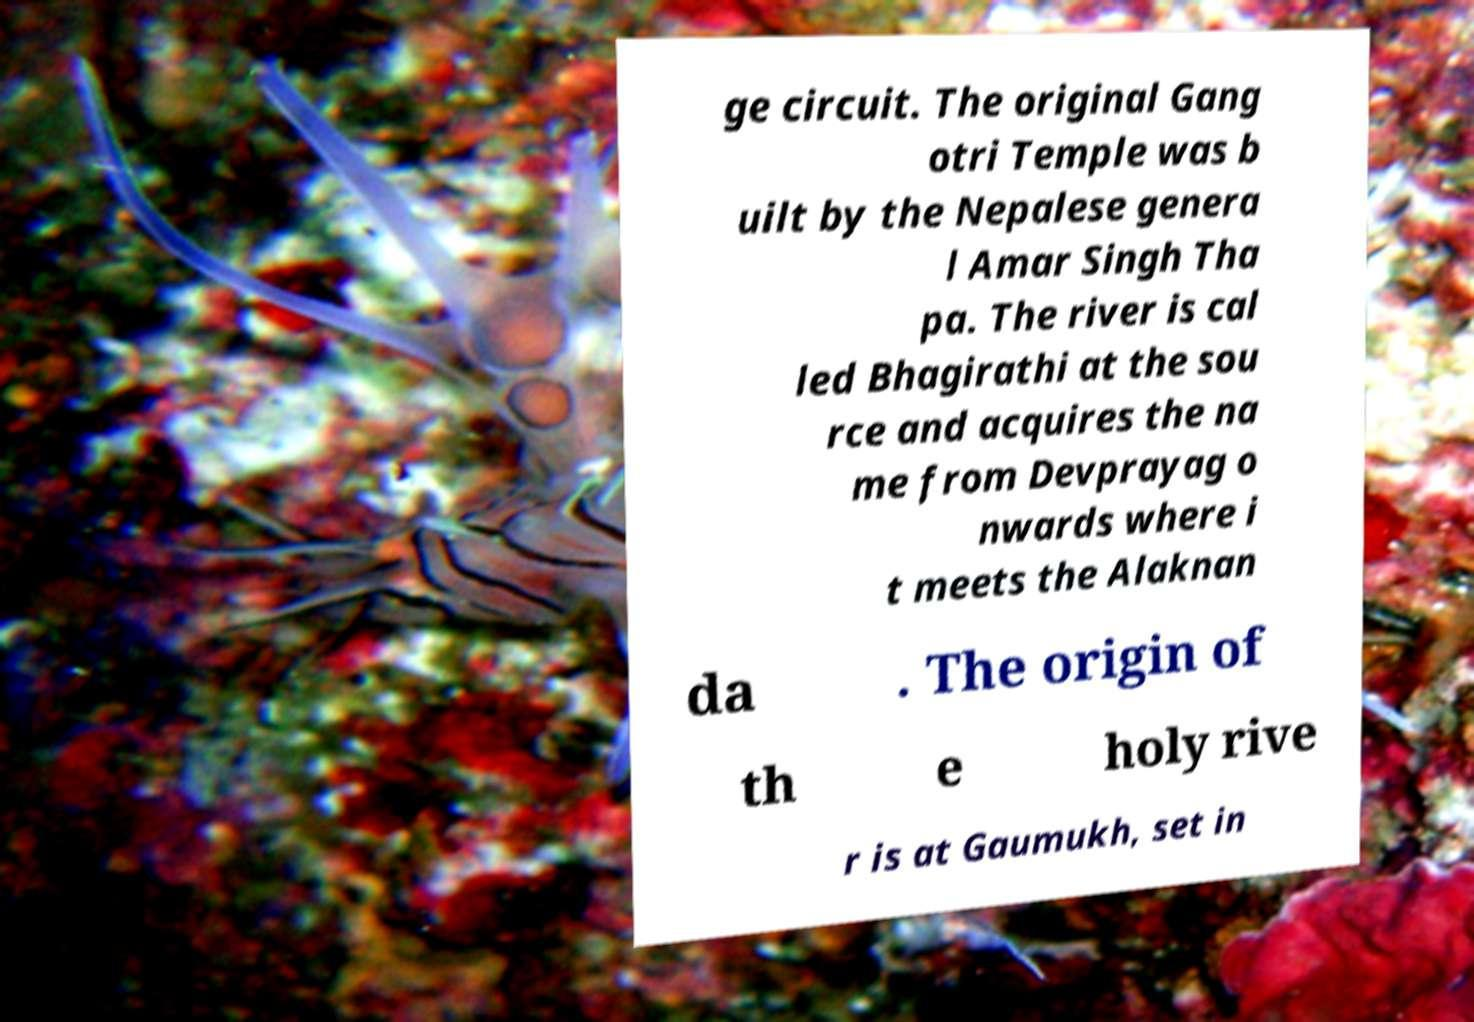I need the written content from this picture converted into text. Can you do that? ge circuit. The original Gang otri Temple was b uilt by the Nepalese genera l Amar Singh Tha pa. The river is cal led Bhagirathi at the sou rce and acquires the na me from Devprayag o nwards where i t meets the Alaknan da . The origin of th e holy rive r is at Gaumukh, set in 